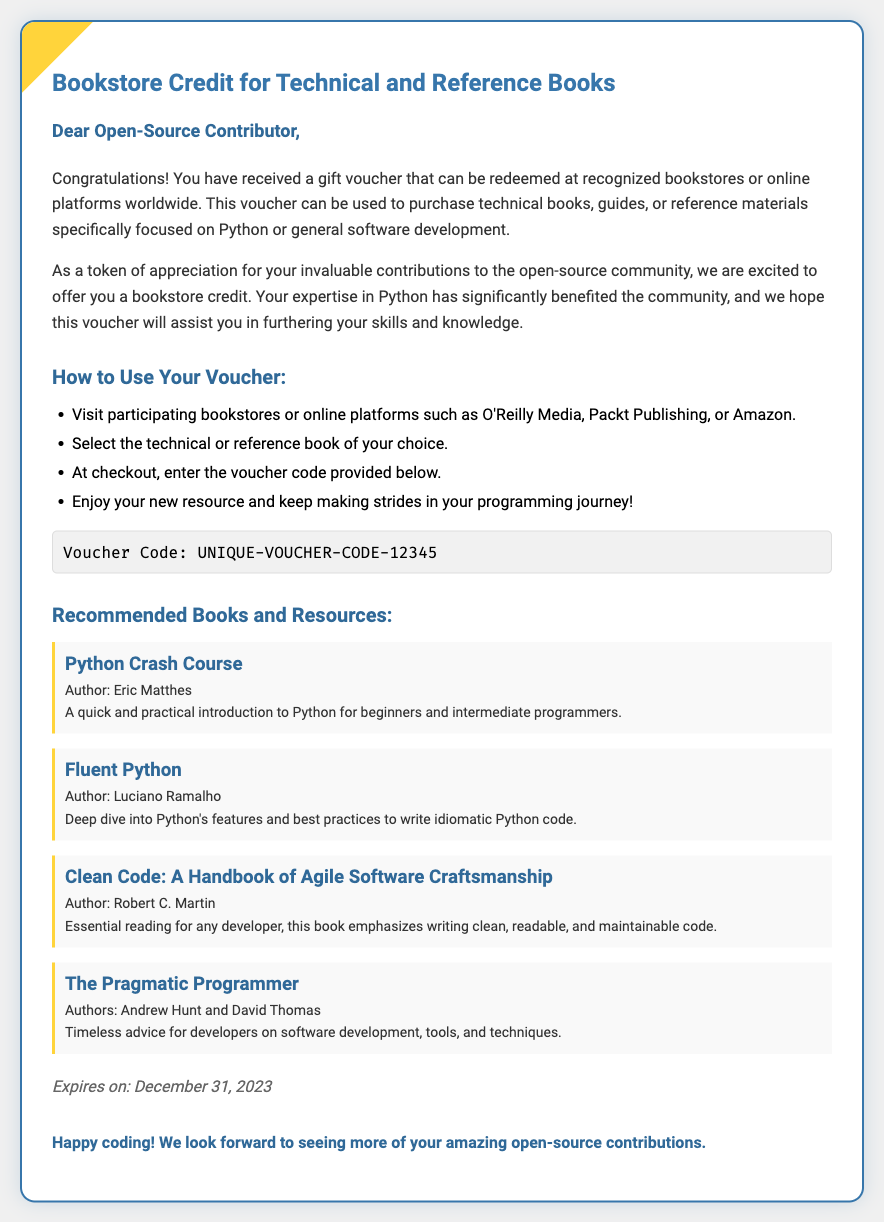What is the title of the voucher? The title of the voucher is displayed prominently at the top of the document.
Answer: Bookstore Credit for Technical and Reference Books Who is the recipient of the voucher? The document addresses the recipient directly at the beginning, highlighting their recognition.
Answer: Dear Open-Source Contributor What can the voucher be used for? The document specifies the purpose of the voucher, indicating what types of books can be purchased.
Answer: Technical and reference books Which online platforms are mentioned for voucher redemption? The document lists specific bookstores and online platforms where the voucher can be used.
Answer: O'Reilly Media, Packt Publishing, Amazon What is the expiration date of the voucher? The document includes an expiration date for the voucher near the end.
Answer: December 31, 2023 Name one recommended book mentioned in the document. The document provides a list of recommended books as examples.
Answer: Python Crash Course What is the author of "Clean Code"? The document mentions the author of a specific recommended book.
Answer: Robert C. Martin How should you apply the voucher code? The instructions on how to utilize the voucher are clearly outlined.
Answer: At checkout What is the voucher code provided in the document? The voucher code is presented in a distinct section of the document.
Answer: UNIQUE-VOUCHER-CODE-12345 